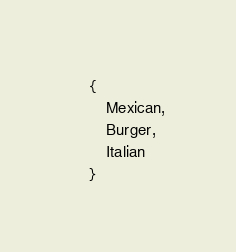<code> <loc_0><loc_0><loc_500><loc_500><_TypeScript_>    {
        Mexican,
        Burger,
        Italian
    }
</code> 